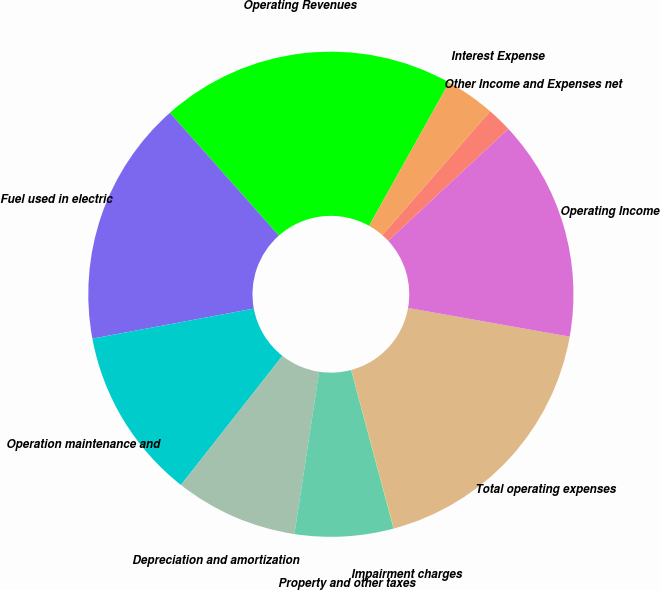Convert chart. <chart><loc_0><loc_0><loc_500><loc_500><pie_chart><fcel>Operating Revenues<fcel>Fuel used in electric<fcel>Operation maintenance and<fcel>Depreciation and amortization<fcel>Property and other taxes<fcel>Impairment charges<fcel>Total operating expenses<fcel>Operating Income<fcel>Other Income and Expenses net<fcel>Interest Expense<nl><fcel>19.65%<fcel>16.38%<fcel>11.47%<fcel>8.2%<fcel>6.56%<fcel>0.02%<fcel>18.02%<fcel>14.74%<fcel>1.66%<fcel>3.29%<nl></chart> 